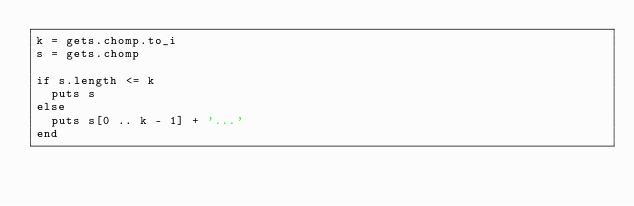Convert code to text. <code><loc_0><loc_0><loc_500><loc_500><_Ruby_>k = gets.chomp.to_i
s = gets.chomp

if s.length <= k
  puts s
else
  puts s[0 .. k - 1] + '...'
end
</code> 